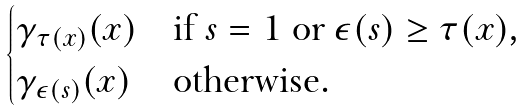Convert formula to latex. <formula><loc_0><loc_0><loc_500><loc_500>\begin{cases} \gamma _ { \tau ( x ) } ( x ) & \text {if $s=1$ or $\epsilon(s) \geq \tau(x)$,} \\ \gamma _ { \epsilon ( s ) } ( x ) & \text {otherwise.} \\ \end{cases}</formula> 